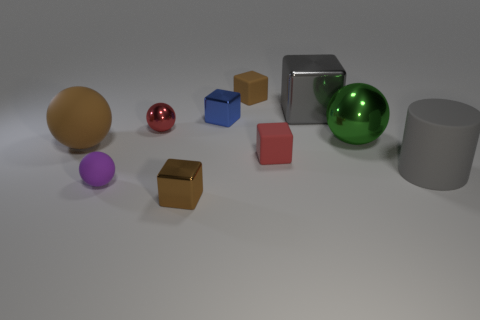Can you describe the lighting and shadows in the scene? The lighting in the image seems to be diffused overhead lighting, as indicated by soft shadows under the objects. The shadows are not very pronounced but extend opposite the apparent light source, suggesting a single, broad light source above. 